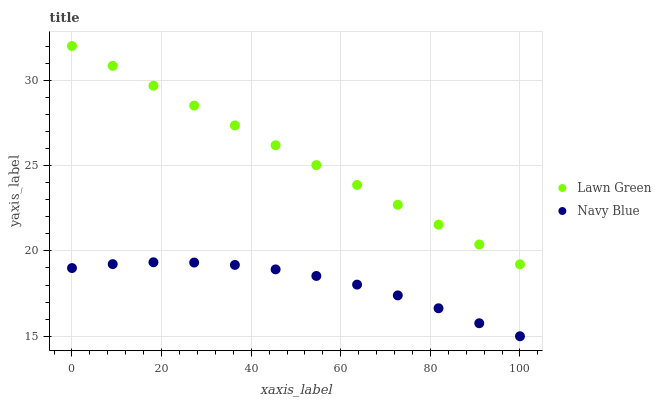Does Navy Blue have the minimum area under the curve?
Answer yes or no. Yes. Does Lawn Green have the maximum area under the curve?
Answer yes or no. Yes. Does Navy Blue have the maximum area under the curve?
Answer yes or no. No. Is Lawn Green the smoothest?
Answer yes or no. Yes. Is Navy Blue the roughest?
Answer yes or no. Yes. Is Navy Blue the smoothest?
Answer yes or no. No. Does Navy Blue have the lowest value?
Answer yes or no. Yes. Does Lawn Green have the highest value?
Answer yes or no. Yes. Does Navy Blue have the highest value?
Answer yes or no. No. Is Navy Blue less than Lawn Green?
Answer yes or no. Yes. Is Lawn Green greater than Navy Blue?
Answer yes or no. Yes. Does Navy Blue intersect Lawn Green?
Answer yes or no. No. 